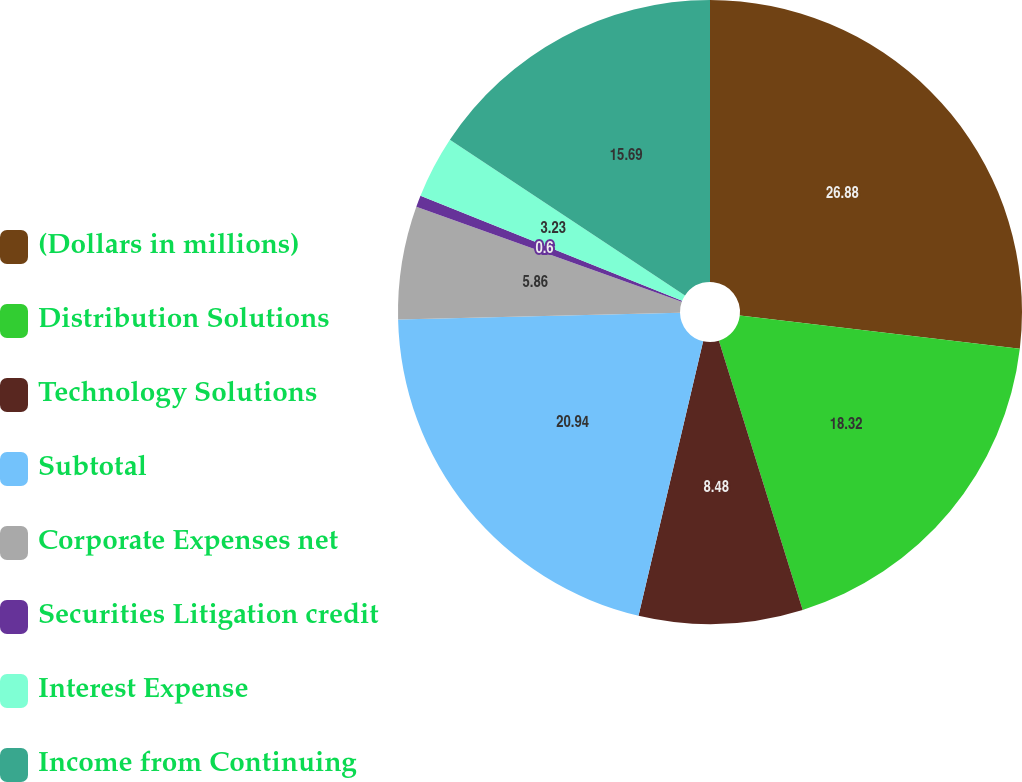Convert chart. <chart><loc_0><loc_0><loc_500><loc_500><pie_chart><fcel>(Dollars in millions)<fcel>Distribution Solutions<fcel>Technology Solutions<fcel>Subtotal<fcel>Corporate Expenses net<fcel>Securities Litigation credit<fcel>Interest Expense<fcel>Income from Continuing<nl><fcel>26.88%<fcel>18.32%<fcel>8.48%<fcel>20.94%<fcel>5.86%<fcel>0.6%<fcel>3.23%<fcel>15.69%<nl></chart> 